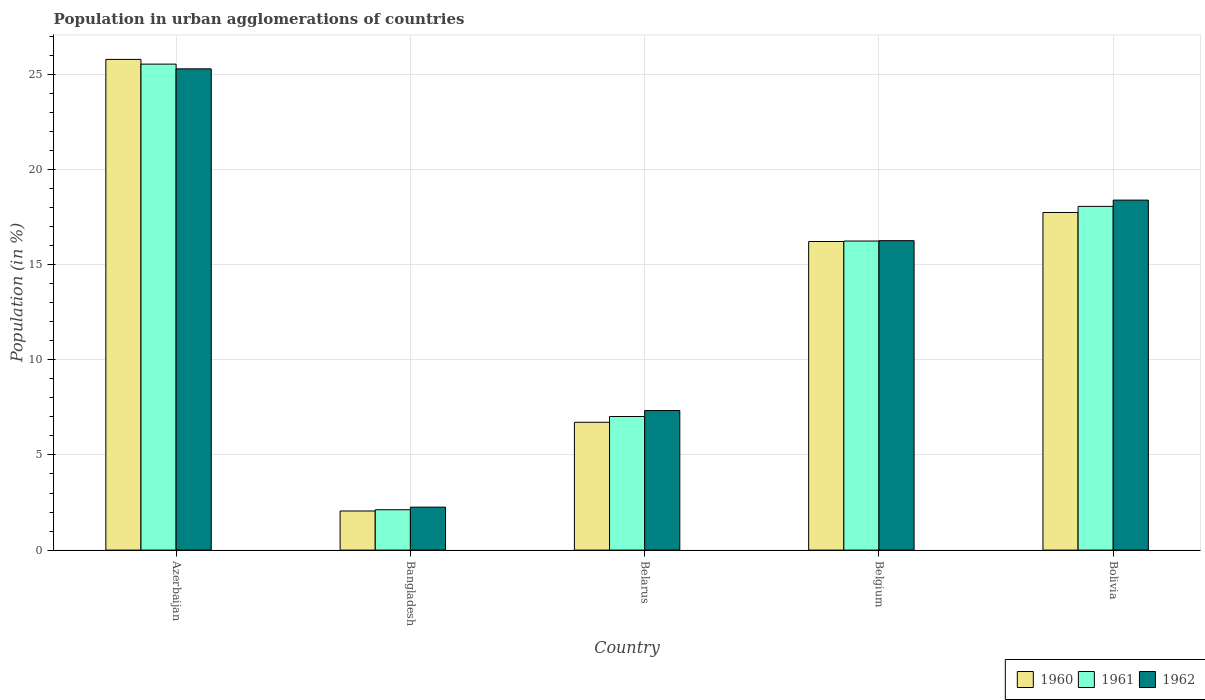How many different coloured bars are there?
Provide a succinct answer. 3. How many groups of bars are there?
Keep it short and to the point. 5. How many bars are there on the 3rd tick from the left?
Keep it short and to the point. 3. What is the percentage of population in urban agglomerations in 1962 in Bangladesh?
Provide a short and direct response. 2.26. Across all countries, what is the maximum percentage of population in urban agglomerations in 1960?
Make the answer very short. 25.79. Across all countries, what is the minimum percentage of population in urban agglomerations in 1961?
Offer a very short reply. 2.12. In which country was the percentage of population in urban agglomerations in 1960 maximum?
Your answer should be very brief. Azerbaijan. What is the total percentage of population in urban agglomerations in 1960 in the graph?
Provide a succinct answer. 68.53. What is the difference between the percentage of population in urban agglomerations in 1962 in Bangladesh and that in Belgium?
Offer a terse response. -14.01. What is the difference between the percentage of population in urban agglomerations in 1960 in Bangladesh and the percentage of population in urban agglomerations in 1961 in Belgium?
Your answer should be compact. -14.19. What is the average percentage of population in urban agglomerations in 1961 per country?
Your response must be concise. 13.8. What is the difference between the percentage of population in urban agglomerations of/in 1961 and percentage of population in urban agglomerations of/in 1962 in Azerbaijan?
Your response must be concise. 0.25. In how many countries, is the percentage of population in urban agglomerations in 1962 greater than 25 %?
Provide a short and direct response. 1. What is the ratio of the percentage of population in urban agglomerations in 1962 in Belgium to that in Bolivia?
Provide a short and direct response. 0.88. Is the percentage of population in urban agglomerations in 1962 in Azerbaijan less than that in Bangladesh?
Offer a terse response. No. What is the difference between the highest and the second highest percentage of population in urban agglomerations in 1961?
Your response must be concise. -9.3. What is the difference between the highest and the lowest percentage of population in urban agglomerations in 1962?
Provide a short and direct response. 23.04. Is the sum of the percentage of population in urban agglomerations in 1961 in Azerbaijan and Belarus greater than the maximum percentage of population in urban agglomerations in 1962 across all countries?
Give a very brief answer. Yes. How many countries are there in the graph?
Offer a terse response. 5. Are the values on the major ticks of Y-axis written in scientific E-notation?
Make the answer very short. No. Does the graph contain any zero values?
Your response must be concise. No. Where does the legend appear in the graph?
Your answer should be compact. Bottom right. How many legend labels are there?
Provide a succinct answer. 3. How are the legend labels stacked?
Provide a succinct answer. Horizontal. What is the title of the graph?
Ensure brevity in your answer.  Population in urban agglomerations of countries. What is the Population (in %) of 1960 in Azerbaijan?
Your response must be concise. 25.79. What is the Population (in %) in 1961 in Azerbaijan?
Your answer should be compact. 25.54. What is the Population (in %) of 1962 in Azerbaijan?
Your answer should be compact. 25.29. What is the Population (in %) of 1960 in Bangladesh?
Your response must be concise. 2.06. What is the Population (in %) of 1961 in Bangladesh?
Ensure brevity in your answer.  2.12. What is the Population (in %) in 1962 in Bangladesh?
Offer a terse response. 2.26. What is the Population (in %) of 1960 in Belarus?
Offer a terse response. 6.72. What is the Population (in %) in 1961 in Belarus?
Ensure brevity in your answer.  7.02. What is the Population (in %) in 1962 in Belarus?
Your response must be concise. 7.34. What is the Population (in %) of 1960 in Belgium?
Your answer should be compact. 16.22. What is the Population (in %) in 1961 in Belgium?
Ensure brevity in your answer.  16.24. What is the Population (in %) in 1962 in Belgium?
Your answer should be very brief. 16.26. What is the Population (in %) of 1960 in Bolivia?
Make the answer very short. 17.75. What is the Population (in %) of 1961 in Bolivia?
Provide a short and direct response. 18.07. What is the Population (in %) of 1962 in Bolivia?
Keep it short and to the point. 18.4. Across all countries, what is the maximum Population (in %) of 1960?
Provide a short and direct response. 25.79. Across all countries, what is the maximum Population (in %) of 1961?
Keep it short and to the point. 25.54. Across all countries, what is the maximum Population (in %) in 1962?
Offer a very short reply. 25.29. Across all countries, what is the minimum Population (in %) in 1960?
Ensure brevity in your answer.  2.06. Across all countries, what is the minimum Population (in %) of 1961?
Provide a short and direct response. 2.12. Across all countries, what is the minimum Population (in %) of 1962?
Make the answer very short. 2.26. What is the total Population (in %) of 1960 in the graph?
Provide a short and direct response. 68.53. What is the total Population (in %) of 1961 in the graph?
Your answer should be very brief. 69. What is the total Population (in %) in 1962 in the graph?
Ensure brevity in your answer.  69.55. What is the difference between the Population (in %) in 1960 in Azerbaijan and that in Bangladesh?
Offer a very short reply. 23.74. What is the difference between the Population (in %) in 1961 in Azerbaijan and that in Bangladesh?
Keep it short and to the point. 23.42. What is the difference between the Population (in %) in 1962 in Azerbaijan and that in Bangladesh?
Provide a short and direct response. 23.04. What is the difference between the Population (in %) of 1960 in Azerbaijan and that in Belarus?
Offer a very short reply. 19.07. What is the difference between the Population (in %) in 1961 in Azerbaijan and that in Belarus?
Your response must be concise. 18.52. What is the difference between the Population (in %) in 1962 in Azerbaijan and that in Belarus?
Make the answer very short. 17.96. What is the difference between the Population (in %) of 1960 in Azerbaijan and that in Belgium?
Offer a very short reply. 9.57. What is the difference between the Population (in %) in 1961 in Azerbaijan and that in Belgium?
Provide a short and direct response. 9.3. What is the difference between the Population (in %) in 1962 in Azerbaijan and that in Belgium?
Give a very brief answer. 9.03. What is the difference between the Population (in %) in 1960 in Azerbaijan and that in Bolivia?
Provide a succinct answer. 8.05. What is the difference between the Population (in %) of 1961 in Azerbaijan and that in Bolivia?
Your answer should be compact. 7.48. What is the difference between the Population (in %) of 1962 in Azerbaijan and that in Bolivia?
Your answer should be very brief. 6.9. What is the difference between the Population (in %) of 1960 in Bangladesh and that in Belarus?
Give a very brief answer. -4.66. What is the difference between the Population (in %) in 1961 in Bangladesh and that in Belarus?
Keep it short and to the point. -4.9. What is the difference between the Population (in %) of 1962 in Bangladesh and that in Belarus?
Provide a short and direct response. -5.08. What is the difference between the Population (in %) of 1960 in Bangladesh and that in Belgium?
Keep it short and to the point. -14.16. What is the difference between the Population (in %) in 1961 in Bangladesh and that in Belgium?
Your response must be concise. -14.12. What is the difference between the Population (in %) in 1962 in Bangladesh and that in Belgium?
Ensure brevity in your answer.  -14.01. What is the difference between the Population (in %) of 1960 in Bangladesh and that in Bolivia?
Keep it short and to the point. -15.69. What is the difference between the Population (in %) in 1961 in Bangladesh and that in Bolivia?
Offer a very short reply. -15.95. What is the difference between the Population (in %) in 1962 in Bangladesh and that in Bolivia?
Your answer should be compact. -16.14. What is the difference between the Population (in %) of 1960 in Belarus and that in Belgium?
Keep it short and to the point. -9.5. What is the difference between the Population (in %) of 1961 in Belarus and that in Belgium?
Offer a terse response. -9.22. What is the difference between the Population (in %) in 1962 in Belarus and that in Belgium?
Give a very brief answer. -8.93. What is the difference between the Population (in %) in 1960 in Belarus and that in Bolivia?
Keep it short and to the point. -11.03. What is the difference between the Population (in %) of 1961 in Belarus and that in Bolivia?
Offer a terse response. -11.04. What is the difference between the Population (in %) in 1962 in Belarus and that in Bolivia?
Provide a succinct answer. -11.06. What is the difference between the Population (in %) in 1960 in Belgium and that in Bolivia?
Give a very brief answer. -1.53. What is the difference between the Population (in %) in 1961 in Belgium and that in Bolivia?
Your answer should be very brief. -1.82. What is the difference between the Population (in %) of 1962 in Belgium and that in Bolivia?
Your response must be concise. -2.13. What is the difference between the Population (in %) in 1960 in Azerbaijan and the Population (in %) in 1961 in Bangladesh?
Your answer should be compact. 23.67. What is the difference between the Population (in %) in 1960 in Azerbaijan and the Population (in %) in 1962 in Bangladesh?
Make the answer very short. 23.53. What is the difference between the Population (in %) of 1961 in Azerbaijan and the Population (in %) of 1962 in Bangladesh?
Give a very brief answer. 23.28. What is the difference between the Population (in %) of 1960 in Azerbaijan and the Population (in %) of 1961 in Belarus?
Offer a terse response. 18.77. What is the difference between the Population (in %) of 1960 in Azerbaijan and the Population (in %) of 1962 in Belarus?
Give a very brief answer. 18.46. What is the difference between the Population (in %) of 1961 in Azerbaijan and the Population (in %) of 1962 in Belarus?
Provide a succinct answer. 18.21. What is the difference between the Population (in %) of 1960 in Azerbaijan and the Population (in %) of 1961 in Belgium?
Keep it short and to the point. 9.55. What is the difference between the Population (in %) of 1960 in Azerbaijan and the Population (in %) of 1962 in Belgium?
Provide a succinct answer. 9.53. What is the difference between the Population (in %) in 1961 in Azerbaijan and the Population (in %) in 1962 in Belgium?
Your response must be concise. 9.28. What is the difference between the Population (in %) in 1960 in Azerbaijan and the Population (in %) in 1961 in Bolivia?
Your response must be concise. 7.72. What is the difference between the Population (in %) in 1960 in Azerbaijan and the Population (in %) in 1962 in Bolivia?
Keep it short and to the point. 7.4. What is the difference between the Population (in %) of 1961 in Azerbaijan and the Population (in %) of 1962 in Bolivia?
Your response must be concise. 7.15. What is the difference between the Population (in %) of 1960 in Bangladesh and the Population (in %) of 1961 in Belarus?
Your answer should be very brief. -4.97. What is the difference between the Population (in %) in 1960 in Bangladesh and the Population (in %) in 1962 in Belarus?
Offer a terse response. -5.28. What is the difference between the Population (in %) of 1961 in Bangladesh and the Population (in %) of 1962 in Belarus?
Keep it short and to the point. -5.21. What is the difference between the Population (in %) in 1960 in Bangladesh and the Population (in %) in 1961 in Belgium?
Your response must be concise. -14.19. What is the difference between the Population (in %) of 1960 in Bangladesh and the Population (in %) of 1962 in Belgium?
Make the answer very short. -14.21. What is the difference between the Population (in %) of 1961 in Bangladesh and the Population (in %) of 1962 in Belgium?
Offer a very short reply. -14.14. What is the difference between the Population (in %) of 1960 in Bangladesh and the Population (in %) of 1961 in Bolivia?
Keep it short and to the point. -16.01. What is the difference between the Population (in %) of 1960 in Bangladesh and the Population (in %) of 1962 in Bolivia?
Give a very brief answer. -16.34. What is the difference between the Population (in %) of 1961 in Bangladesh and the Population (in %) of 1962 in Bolivia?
Offer a terse response. -16.27. What is the difference between the Population (in %) in 1960 in Belarus and the Population (in %) in 1961 in Belgium?
Your answer should be compact. -9.53. What is the difference between the Population (in %) in 1960 in Belarus and the Population (in %) in 1962 in Belgium?
Provide a short and direct response. -9.55. What is the difference between the Population (in %) of 1961 in Belarus and the Population (in %) of 1962 in Belgium?
Make the answer very short. -9.24. What is the difference between the Population (in %) in 1960 in Belarus and the Population (in %) in 1961 in Bolivia?
Offer a very short reply. -11.35. What is the difference between the Population (in %) of 1960 in Belarus and the Population (in %) of 1962 in Bolivia?
Give a very brief answer. -11.68. What is the difference between the Population (in %) in 1961 in Belarus and the Population (in %) in 1962 in Bolivia?
Keep it short and to the point. -11.37. What is the difference between the Population (in %) in 1960 in Belgium and the Population (in %) in 1961 in Bolivia?
Ensure brevity in your answer.  -1.85. What is the difference between the Population (in %) in 1960 in Belgium and the Population (in %) in 1962 in Bolivia?
Your response must be concise. -2.18. What is the difference between the Population (in %) in 1961 in Belgium and the Population (in %) in 1962 in Bolivia?
Give a very brief answer. -2.15. What is the average Population (in %) of 1960 per country?
Your answer should be very brief. 13.71. What is the average Population (in %) in 1961 per country?
Provide a succinct answer. 13.8. What is the average Population (in %) in 1962 per country?
Provide a short and direct response. 13.91. What is the difference between the Population (in %) in 1960 and Population (in %) in 1961 in Azerbaijan?
Your response must be concise. 0.25. What is the difference between the Population (in %) in 1960 and Population (in %) in 1962 in Azerbaijan?
Offer a terse response. 0.5. What is the difference between the Population (in %) in 1961 and Population (in %) in 1962 in Azerbaijan?
Your answer should be compact. 0.25. What is the difference between the Population (in %) in 1960 and Population (in %) in 1961 in Bangladesh?
Provide a succinct answer. -0.07. What is the difference between the Population (in %) of 1960 and Population (in %) of 1962 in Bangladesh?
Make the answer very short. -0.2. What is the difference between the Population (in %) of 1961 and Population (in %) of 1962 in Bangladesh?
Offer a very short reply. -0.14. What is the difference between the Population (in %) in 1960 and Population (in %) in 1961 in Belarus?
Make the answer very short. -0.3. What is the difference between the Population (in %) in 1960 and Population (in %) in 1962 in Belarus?
Your response must be concise. -0.62. What is the difference between the Population (in %) of 1961 and Population (in %) of 1962 in Belarus?
Offer a very short reply. -0.31. What is the difference between the Population (in %) in 1960 and Population (in %) in 1961 in Belgium?
Ensure brevity in your answer.  -0.02. What is the difference between the Population (in %) in 1960 and Population (in %) in 1962 in Belgium?
Keep it short and to the point. -0.04. What is the difference between the Population (in %) of 1961 and Population (in %) of 1962 in Belgium?
Offer a very short reply. -0.02. What is the difference between the Population (in %) in 1960 and Population (in %) in 1961 in Bolivia?
Offer a terse response. -0.32. What is the difference between the Population (in %) of 1960 and Population (in %) of 1962 in Bolivia?
Offer a terse response. -0.65. What is the difference between the Population (in %) in 1961 and Population (in %) in 1962 in Bolivia?
Your response must be concise. -0.33. What is the ratio of the Population (in %) of 1960 in Azerbaijan to that in Bangladesh?
Make the answer very short. 12.55. What is the ratio of the Population (in %) in 1961 in Azerbaijan to that in Bangladesh?
Your answer should be compact. 12.04. What is the ratio of the Population (in %) in 1962 in Azerbaijan to that in Bangladesh?
Offer a very short reply. 11.2. What is the ratio of the Population (in %) in 1960 in Azerbaijan to that in Belarus?
Ensure brevity in your answer.  3.84. What is the ratio of the Population (in %) of 1961 in Azerbaijan to that in Belarus?
Offer a very short reply. 3.64. What is the ratio of the Population (in %) of 1962 in Azerbaijan to that in Belarus?
Offer a terse response. 3.45. What is the ratio of the Population (in %) of 1960 in Azerbaijan to that in Belgium?
Your response must be concise. 1.59. What is the ratio of the Population (in %) of 1961 in Azerbaijan to that in Belgium?
Your answer should be very brief. 1.57. What is the ratio of the Population (in %) in 1962 in Azerbaijan to that in Belgium?
Provide a succinct answer. 1.56. What is the ratio of the Population (in %) in 1960 in Azerbaijan to that in Bolivia?
Your answer should be compact. 1.45. What is the ratio of the Population (in %) in 1961 in Azerbaijan to that in Bolivia?
Ensure brevity in your answer.  1.41. What is the ratio of the Population (in %) of 1962 in Azerbaijan to that in Bolivia?
Your answer should be very brief. 1.38. What is the ratio of the Population (in %) in 1960 in Bangladesh to that in Belarus?
Provide a succinct answer. 0.31. What is the ratio of the Population (in %) of 1961 in Bangladesh to that in Belarus?
Keep it short and to the point. 0.3. What is the ratio of the Population (in %) of 1962 in Bangladesh to that in Belarus?
Provide a short and direct response. 0.31. What is the ratio of the Population (in %) of 1960 in Bangladesh to that in Belgium?
Your response must be concise. 0.13. What is the ratio of the Population (in %) in 1961 in Bangladesh to that in Belgium?
Offer a terse response. 0.13. What is the ratio of the Population (in %) in 1962 in Bangladesh to that in Belgium?
Give a very brief answer. 0.14. What is the ratio of the Population (in %) in 1960 in Bangladesh to that in Bolivia?
Keep it short and to the point. 0.12. What is the ratio of the Population (in %) in 1961 in Bangladesh to that in Bolivia?
Offer a very short reply. 0.12. What is the ratio of the Population (in %) in 1962 in Bangladesh to that in Bolivia?
Give a very brief answer. 0.12. What is the ratio of the Population (in %) in 1960 in Belarus to that in Belgium?
Your answer should be compact. 0.41. What is the ratio of the Population (in %) of 1961 in Belarus to that in Belgium?
Make the answer very short. 0.43. What is the ratio of the Population (in %) in 1962 in Belarus to that in Belgium?
Make the answer very short. 0.45. What is the ratio of the Population (in %) in 1960 in Belarus to that in Bolivia?
Make the answer very short. 0.38. What is the ratio of the Population (in %) of 1961 in Belarus to that in Bolivia?
Make the answer very short. 0.39. What is the ratio of the Population (in %) of 1962 in Belarus to that in Bolivia?
Your answer should be very brief. 0.4. What is the ratio of the Population (in %) of 1960 in Belgium to that in Bolivia?
Your answer should be very brief. 0.91. What is the ratio of the Population (in %) of 1961 in Belgium to that in Bolivia?
Offer a very short reply. 0.9. What is the ratio of the Population (in %) in 1962 in Belgium to that in Bolivia?
Offer a very short reply. 0.88. What is the difference between the highest and the second highest Population (in %) in 1960?
Ensure brevity in your answer.  8.05. What is the difference between the highest and the second highest Population (in %) of 1961?
Provide a succinct answer. 7.48. What is the difference between the highest and the second highest Population (in %) in 1962?
Offer a terse response. 6.9. What is the difference between the highest and the lowest Population (in %) in 1960?
Offer a terse response. 23.74. What is the difference between the highest and the lowest Population (in %) in 1961?
Your answer should be compact. 23.42. What is the difference between the highest and the lowest Population (in %) in 1962?
Offer a terse response. 23.04. 